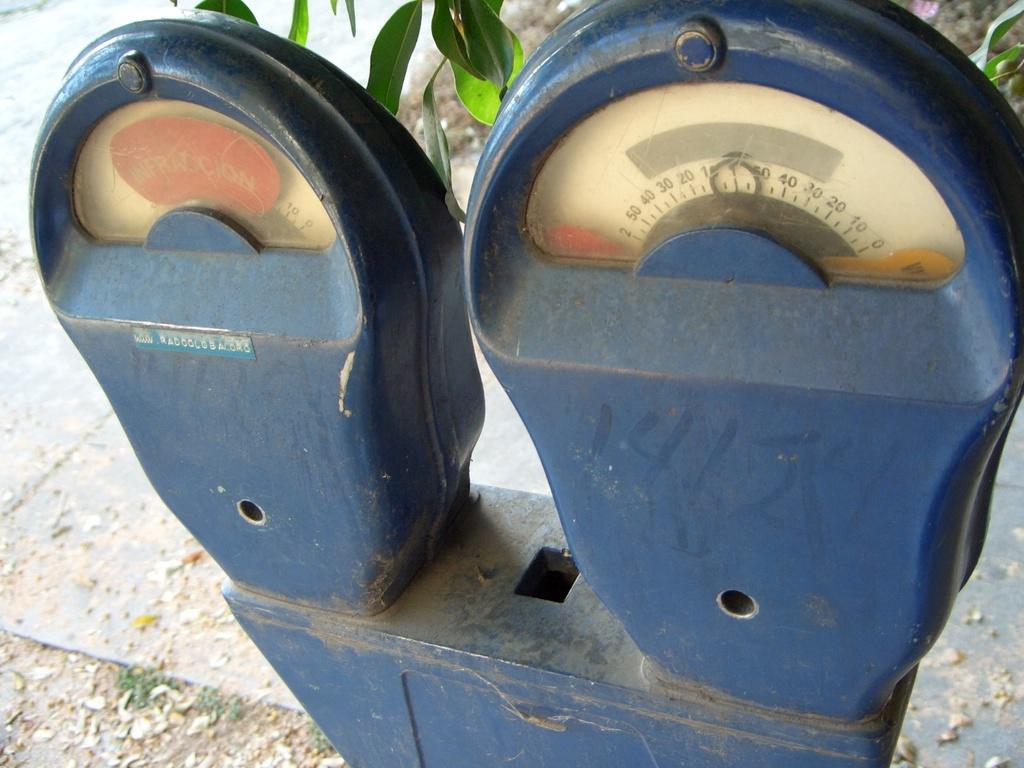How high does the meter go to?
Offer a terse response. 50. 